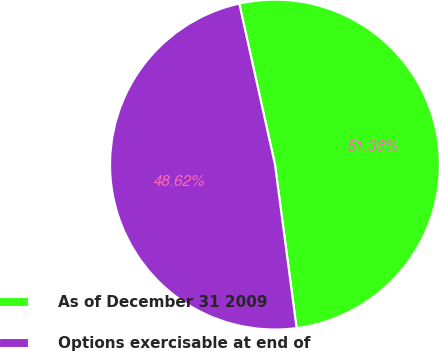Convert chart. <chart><loc_0><loc_0><loc_500><loc_500><pie_chart><fcel>As of December 31 2009<fcel>Options exercisable at end of<nl><fcel>51.38%<fcel>48.62%<nl></chart> 